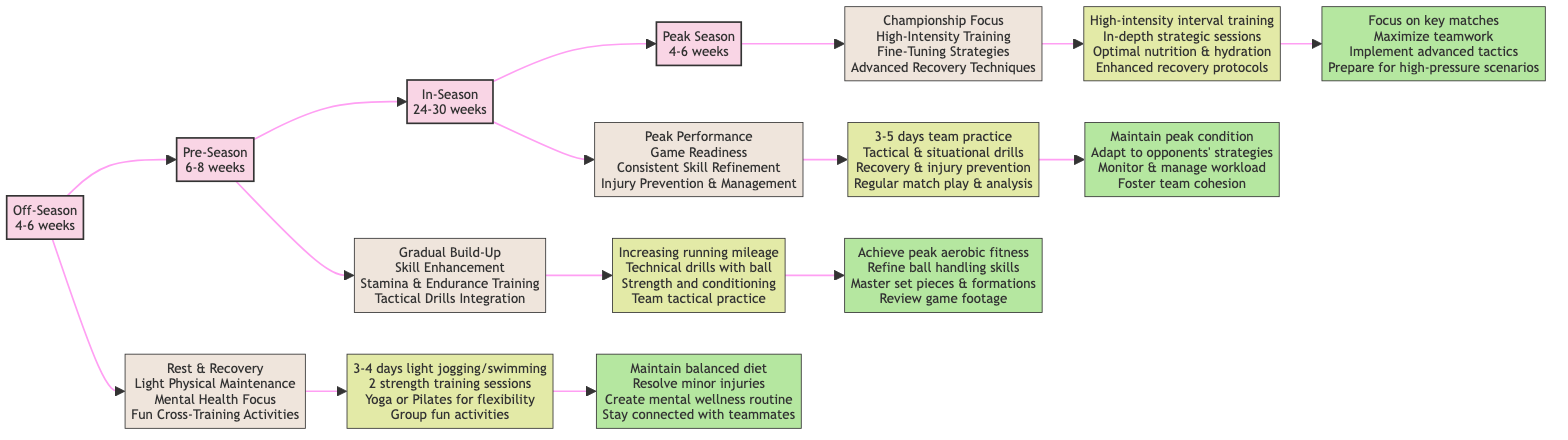What are the goals during the Off-Season phase? The diagram indicates that the goals during the Off-Season phase include: Rest & Recovery, Light Physical Maintenance, Mental Health Focus, and Fun Cross-Training Activities. These goals can be found under the Off-Season node, directly linked to it.
Answer: Rest & Recovery, Light Physical Maintenance, Mental Health Focus, Fun Cross-Training Activities How many weeks does the In-Season phase last? According to the diagram, the In-Season phase lasts for 24-30 weeks, which is specified in the In-Season node as part of the node visualization.
Answer: 24-30 weeks What is the primary focus during the Peak Season? The diagram lists the primary focus during the Peak Season as Championship Focus, High-Intensity Training, Fine-Tuning Strategies, and Advanced Recovery Techniques, which are shown in the goals section of the Peak Season node.
Answer: Championship Focus, High-Intensity Training, Fine-Tuning Strategies, Advanced Recovery Techniques Which phase includes Tactical Drills Integration as a goal? The diagram shows that Tactical Drills Integration is one of the goals during the Pre-Season phase. This can be identified by looking for the goals associated with the Pre-Season node.
Answer: Pre-Season What is the monthly goal for maintaining peak physical condition? The diagram specifies that maintaining peak physical condition is a monthly goal during the In-Season phase, which can be found under the monthly goals linked to the In-Season node.
Answer: Maintain peak physical condition What type of training is emphasized in the weekly goals of the Peak Season? The weekly goals during the Peak Season highlight High-intensity interval training, which can be inferred from the activities listed under the weekly goals of the corresponding Peak Season node.
Answer: High-intensity interval training How many weekly goals are specified for each phase? In examining the diagram, each phase has four weekly goals. This can be seen by counting the number of activities listed under the weekly goals for each phase node.
Answer: 4 What is the final phase in the training regimen progression? The final phase in the training regimen progression, as indicated by the flowchart's structure, is the Peak Season, which is the last node after the In-Season phase.
Answer: Peak Season 